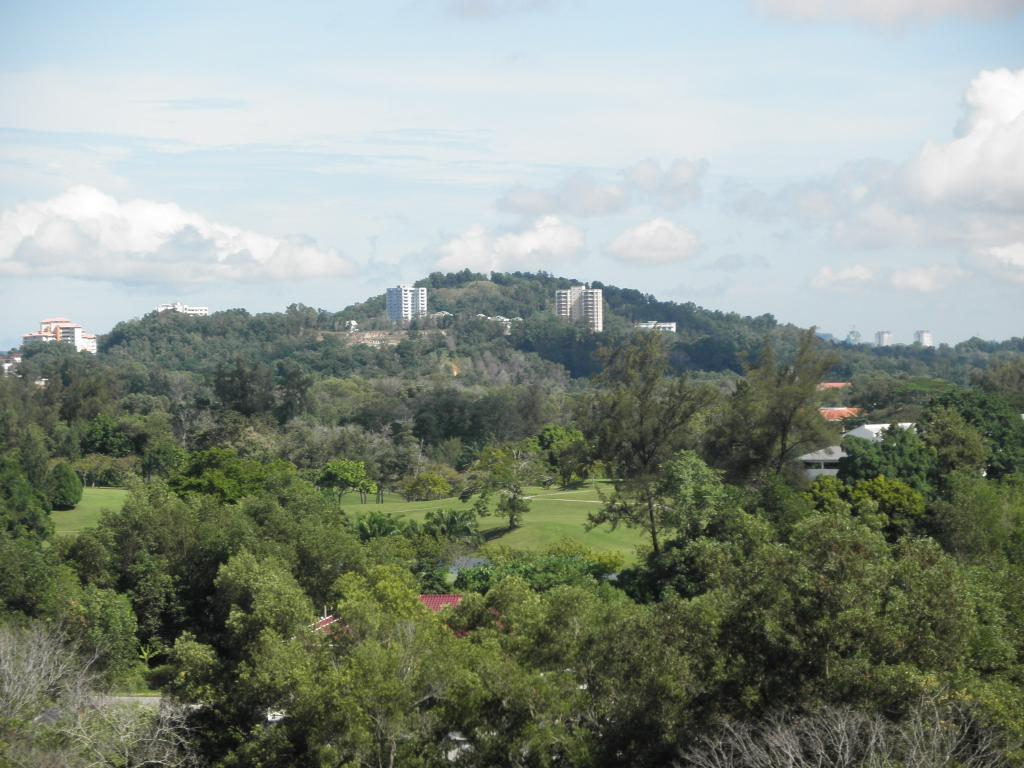What type of vegetation can be seen in the image? There is a group of trees and grass in the image. What type of structures are present in the image? There are houses and buildings in the image. What is visible in the background of the image? The sky is visible in the image. What is the condition of the sky in the image? The sky appears to be cloudy in the image. What color is the coat that the person is wearing in the image? There is no person wearing a coat in the image. What time of day is it in the image, considering the afternoon? The time of day cannot be determined from the image, as there is no indication of the time. 